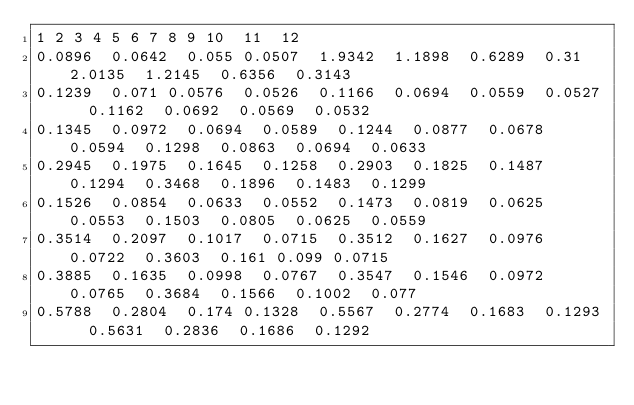<code> <loc_0><loc_0><loc_500><loc_500><_SQL_>1	2	3	4	5	6	7	8	9	10	11	12
0.0896	0.0642	0.055	0.0507	1.9342	1.1898	0.6289	0.31	2.0135	1.2145	0.6356	0.3143
0.1239	0.071	0.0576	0.0526	0.1166	0.0694	0.0559	0.0527	0.1162	0.0692	0.0569	0.0532
0.1345	0.0972	0.0694	0.0589	0.1244	0.0877	0.0678	0.0594	0.1298	0.0863	0.0694	0.0633
0.2945	0.1975	0.1645	0.1258	0.2903	0.1825	0.1487	0.1294	0.3468	0.1896	0.1483	0.1299
0.1526	0.0854	0.0633	0.0552	0.1473	0.0819	0.0625	0.0553	0.1503	0.0805	0.0625	0.0559
0.3514	0.2097	0.1017	0.0715	0.3512	0.1627	0.0976	0.0722	0.3603	0.161	0.099	0.0715
0.3885	0.1635	0.0998	0.0767	0.3547	0.1546	0.0972	0.0765	0.3684	0.1566	0.1002	0.077
0.5788	0.2804	0.174	0.1328	0.5567	0.2774	0.1683	0.1293	0.5631	0.2836	0.1686	0.1292
</code> 